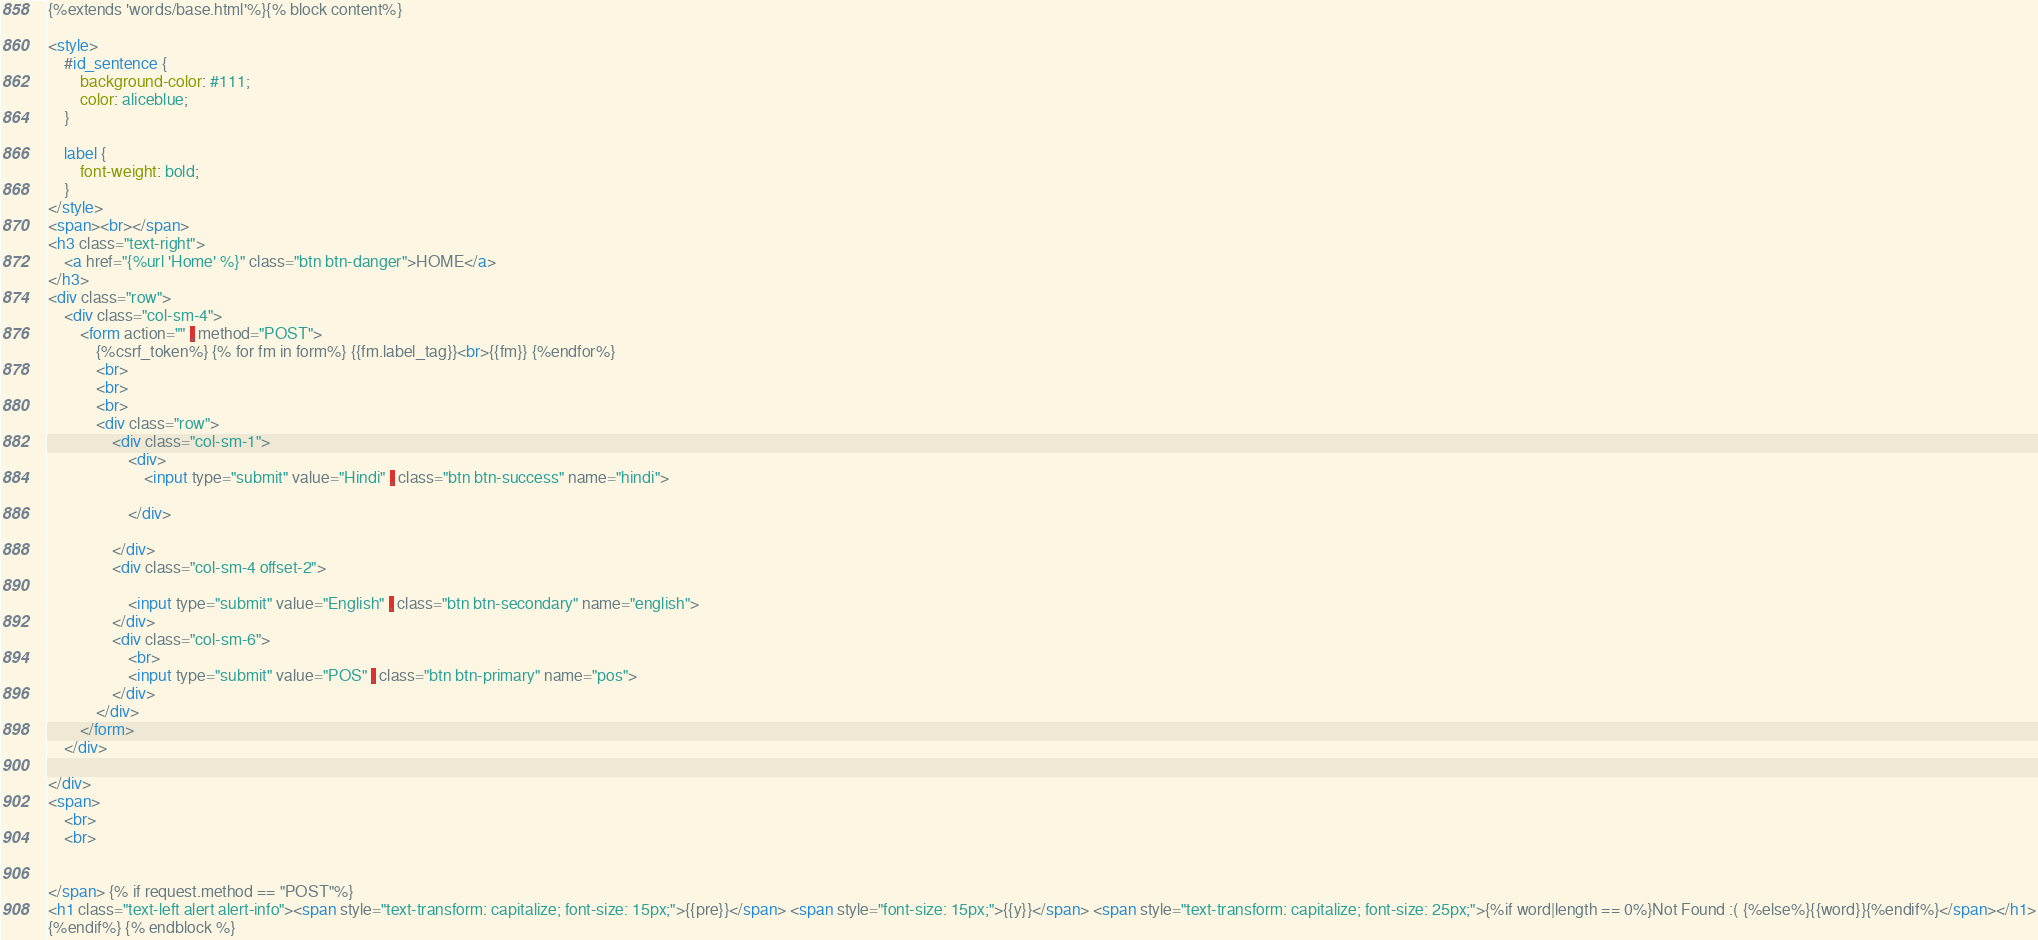<code> <loc_0><loc_0><loc_500><loc_500><_HTML_>{%extends 'words/base.html'%}{% block content%}

<style>
    #id_sentence {
        background-color: #111;
        color: aliceblue;
    }
    
    label {
        font-weight: bold;
    }
</style>
<span><br></span>
<h3 class="text-right">
    <a href="{%url 'Home' %}" class="btn btn-danger">HOME</a>
</h3>
<div class="row">
    <div class="col-sm-4">
        <form action="" , method="POST">
            {%csrf_token%} {% for fm in form%} {{fm.label_tag}}<br>{{fm}} {%endfor%}
            <br>
            <br>
            <br>
            <div class="row">
                <div class="col-sm-1">
                    <div>
                        <input type="submit" value="Hindi" , class="btn btn-success" name="hindi">

                    </div>

                </div>
                <div class="col-sm-4 offset-2">

                    <input type="submit" value="English" , class="btn btn-secondary" name="english">
                </div>
                <div class="col-sm-6">
                    <br>
                    <input type="submit" value="POS" , class="btn btn-primary" name="pos">
                </div>
            </div>
        </form>
    </div>

</div>
<span>
    <br>
    <br>
   
  
</span> {% if request.method == "POST"%}
<h1 class="text-left alert alert-info"><span style="text-transform: capitalize; font-size: 15px;">{{pre}}</span> <span style="font-size: 15px;">{{y}}</span> <span style="text-transform: capitalize; font-size: 25px;">{%if word|length == 0%}Not Found :( {%else%}{{word}}{%endif%}</span></h1>
{%endif%} {% endblock %}</code> 